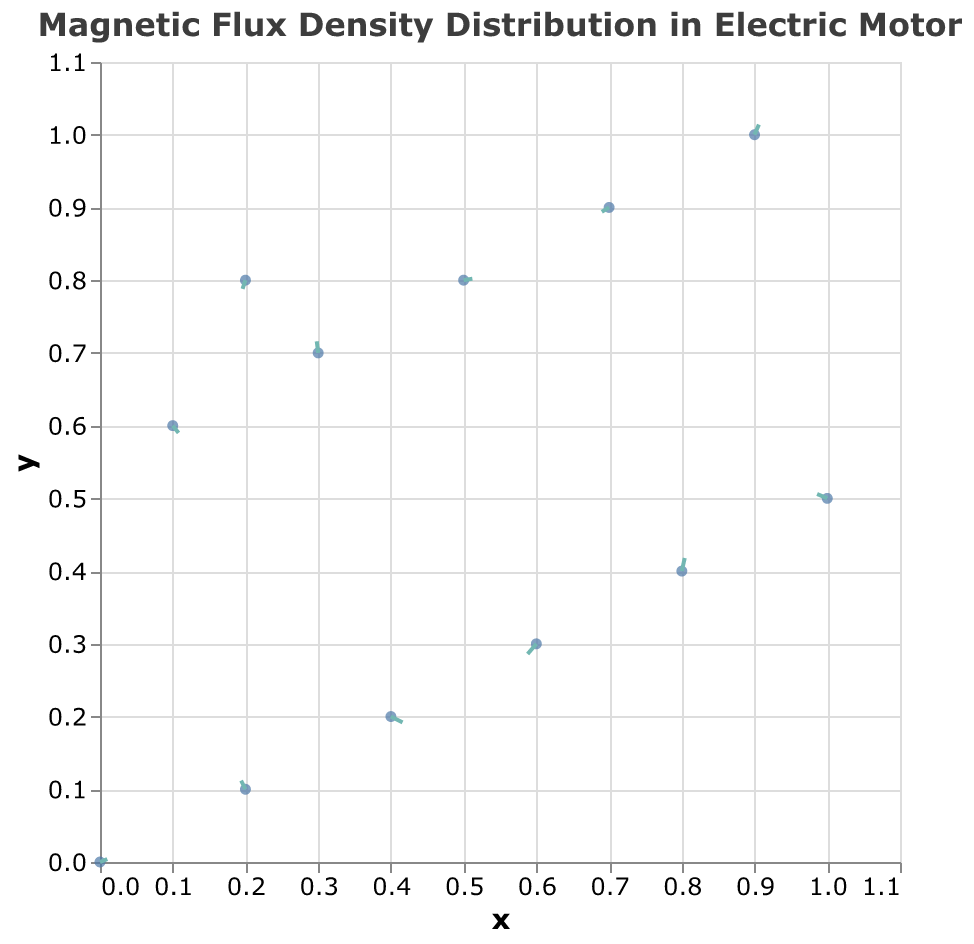What is the title of the plot? The title of the plot can be found at the top, which describes the subject of the visualized data.
Answer: Magnetic Flux Density Distribution in Electric Motor How many data points are shown in the plot? Count the number of points or arrows in the plot, indicating the data points.
Answer: 12 At which rotor position is the magnetic flux density vector (-0.01, 0.08)? Locate the vector with the components (-0.01, 0.08) and check the corresponding rotor position.
Answer: 210 What are the x and y components of the magnetic flux density at rotor position 90? Find the vector corresponding to the rotor position 90 and note its x and y components (Bx and By).
Answer: -0.06, -0.07 Which rotor position has the highest positive x component (Bx) of the magnetic flux density? Compare the Bx values of all rotor positions and identify the highest positive value.
Answer: 60 Which data point shows a magnetic flux density vector pointing downwards (negative y-component)? Look for vectors where the y-component (By) is negative and identify the corresponding data point.
Answer: 60 and 90 Which rotor position has the smallest absolute value of the y-component (By) of magnetic flux density? Calculate the absolute values of By for all rotor positions and find the smallest one.
Answer: 240 (By = 0.01) Compare the magnetic flux density at rotor positions 0 and 300. Which one has a larger magnitude? Calculate the magnitude (√(Bx² + By²)) for both positions and compare them.
Answer: 0 What is the direction of the magnetic flux density at rotor position 120? The direction is given by the (Bx, By) components; you can visualize the arrow direction in the plot.
Answer: Upwards (positive y and small positive x) What trend can you observe about the magnetic flux density distribution as the rotor position increases from 0 to 330? Analyze the changes in the direction and magnitude of the magnetic flux density vectors as the rotor position changes.
Answer: The direction and magnitude vary non-linearly, with different vectors pointing in different directions at different positions 